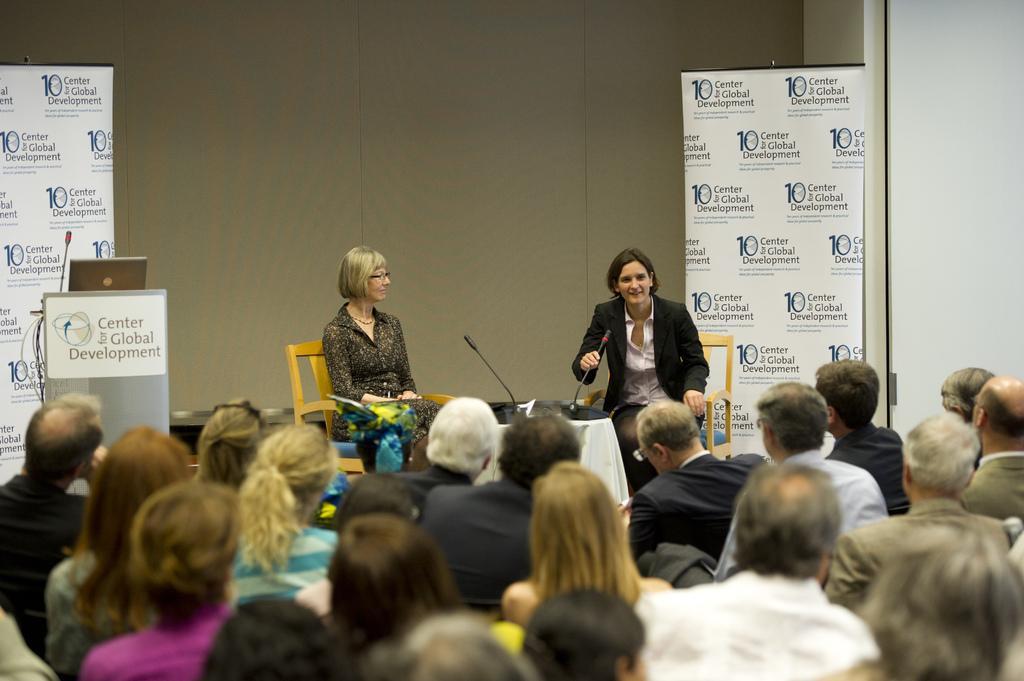Describe this image in one or two sentences. In the foreground of this image, there are persons sitting. In the background, there are two women sitting on the chairs in front of a table on which there are two mics and we can also see a podium with laptop and mic, two banners and the wall. 